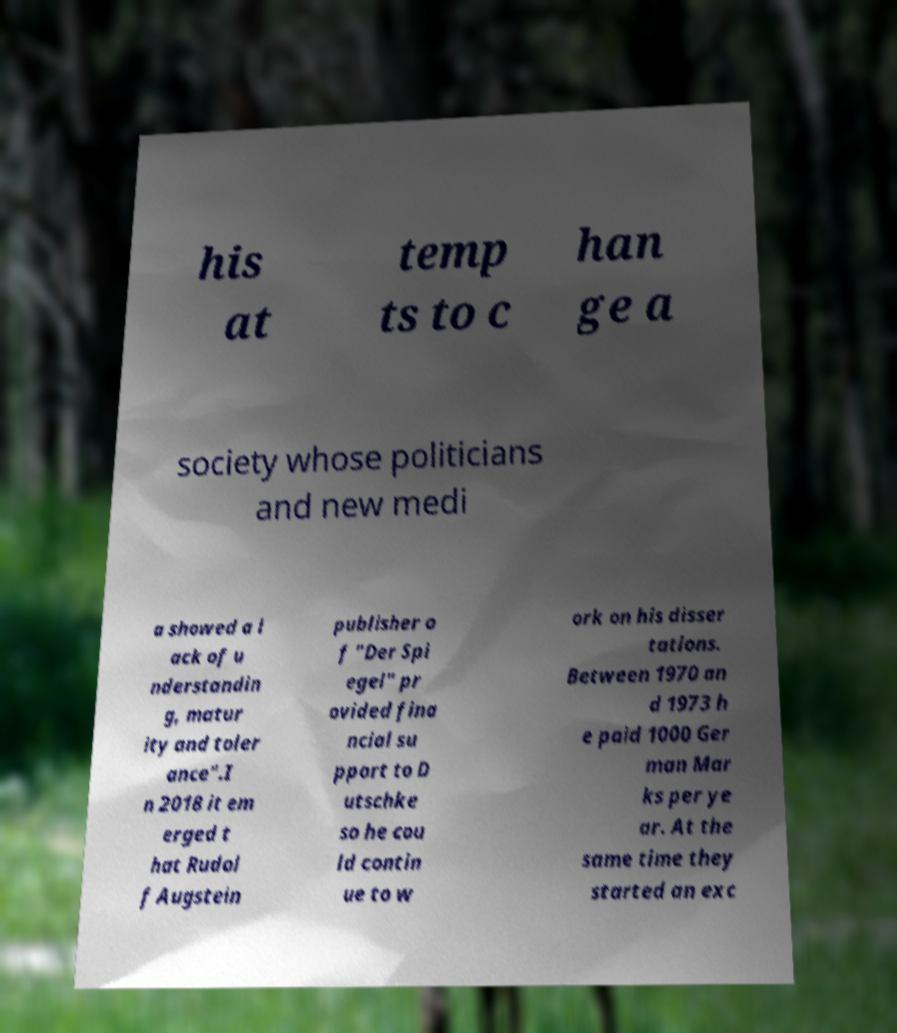There's text embedded in this image that I need extracted. Can you transcribe it verbatim? his at temp ts to c han ge a society whose politicians and new medi a showed a l ack of u nderstandin g, matur ity and toler ance".I n 2018 it em erged t hat Rudol f Augstein publisher o f "Der Spi egel" pr ovided fina ncial su pport to D utschke so he cou ld contin ue to w ork on his disser tations. Between 1970 an d 1973 h e paid 1000 Ger man Mar ks per ye ar. At the same time they started an exc 